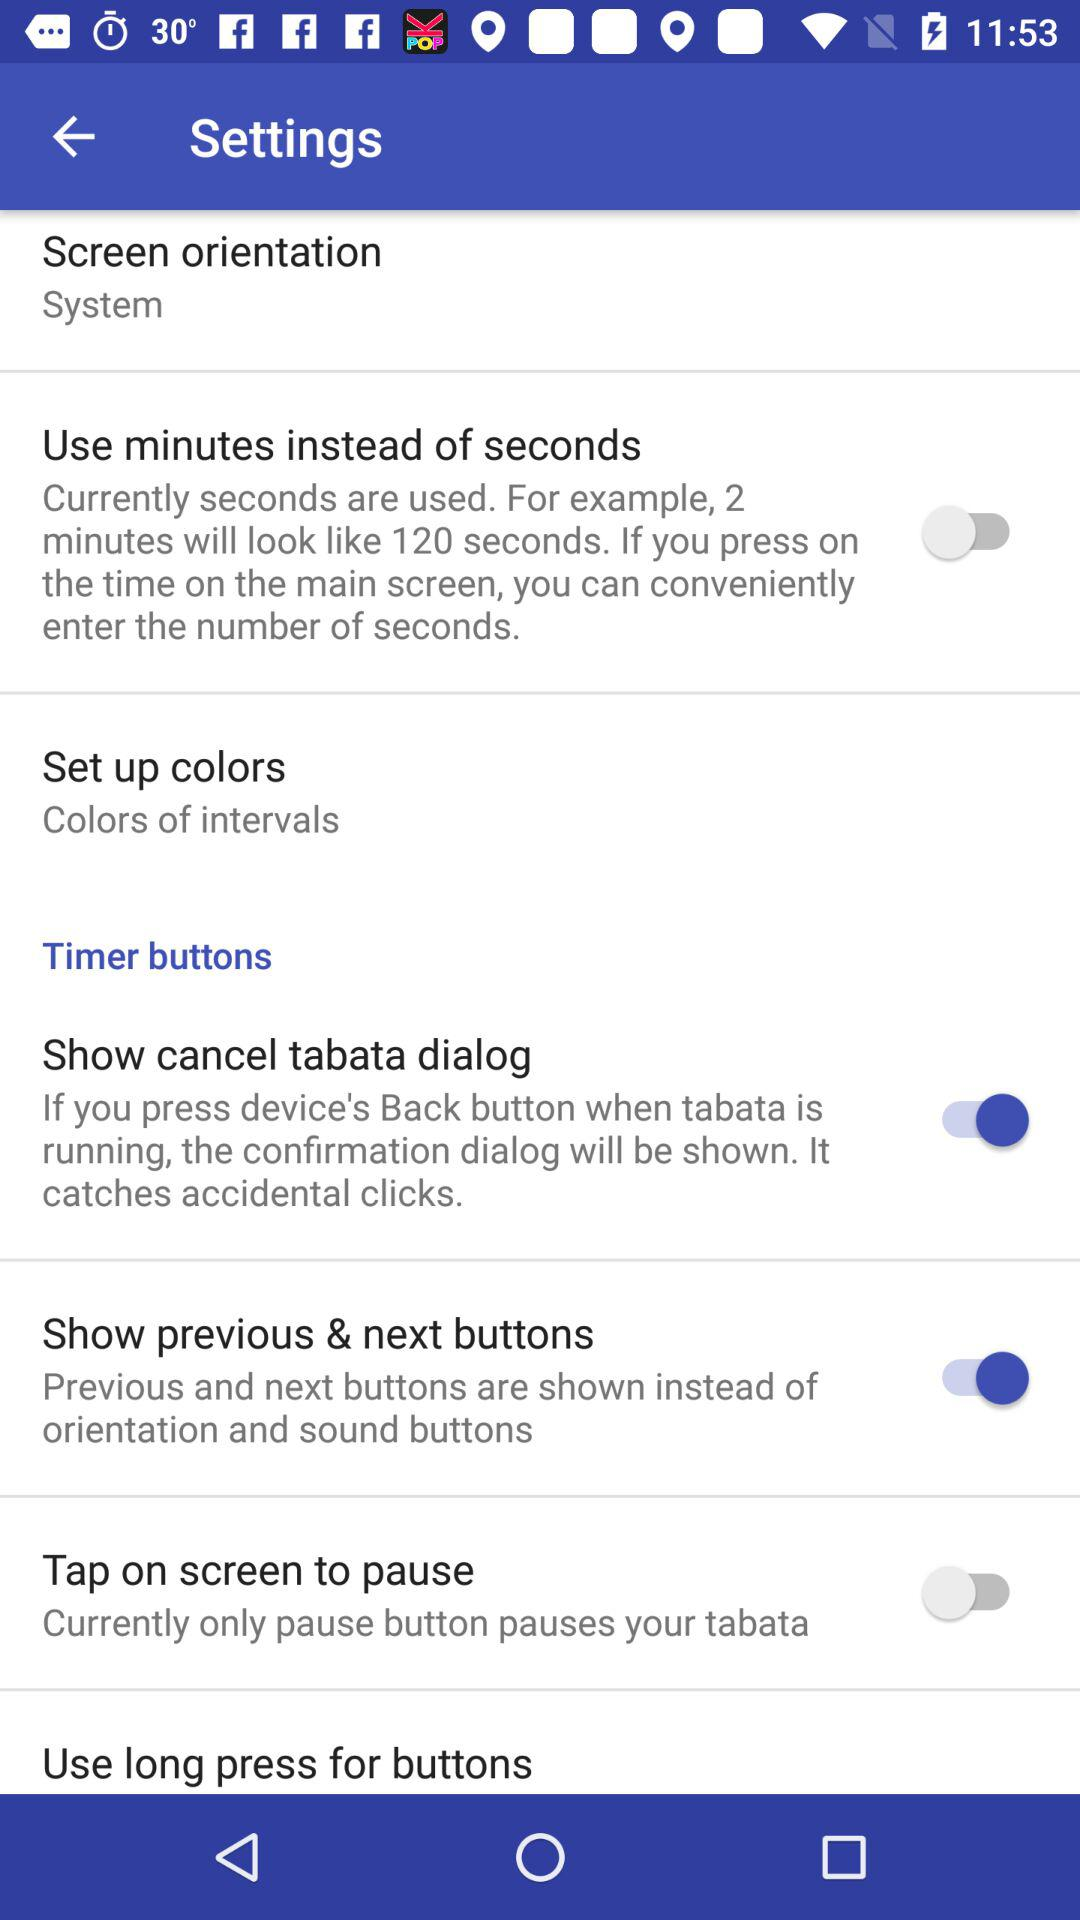What is the status of "Show previous & next buttons"? The status is "on". 